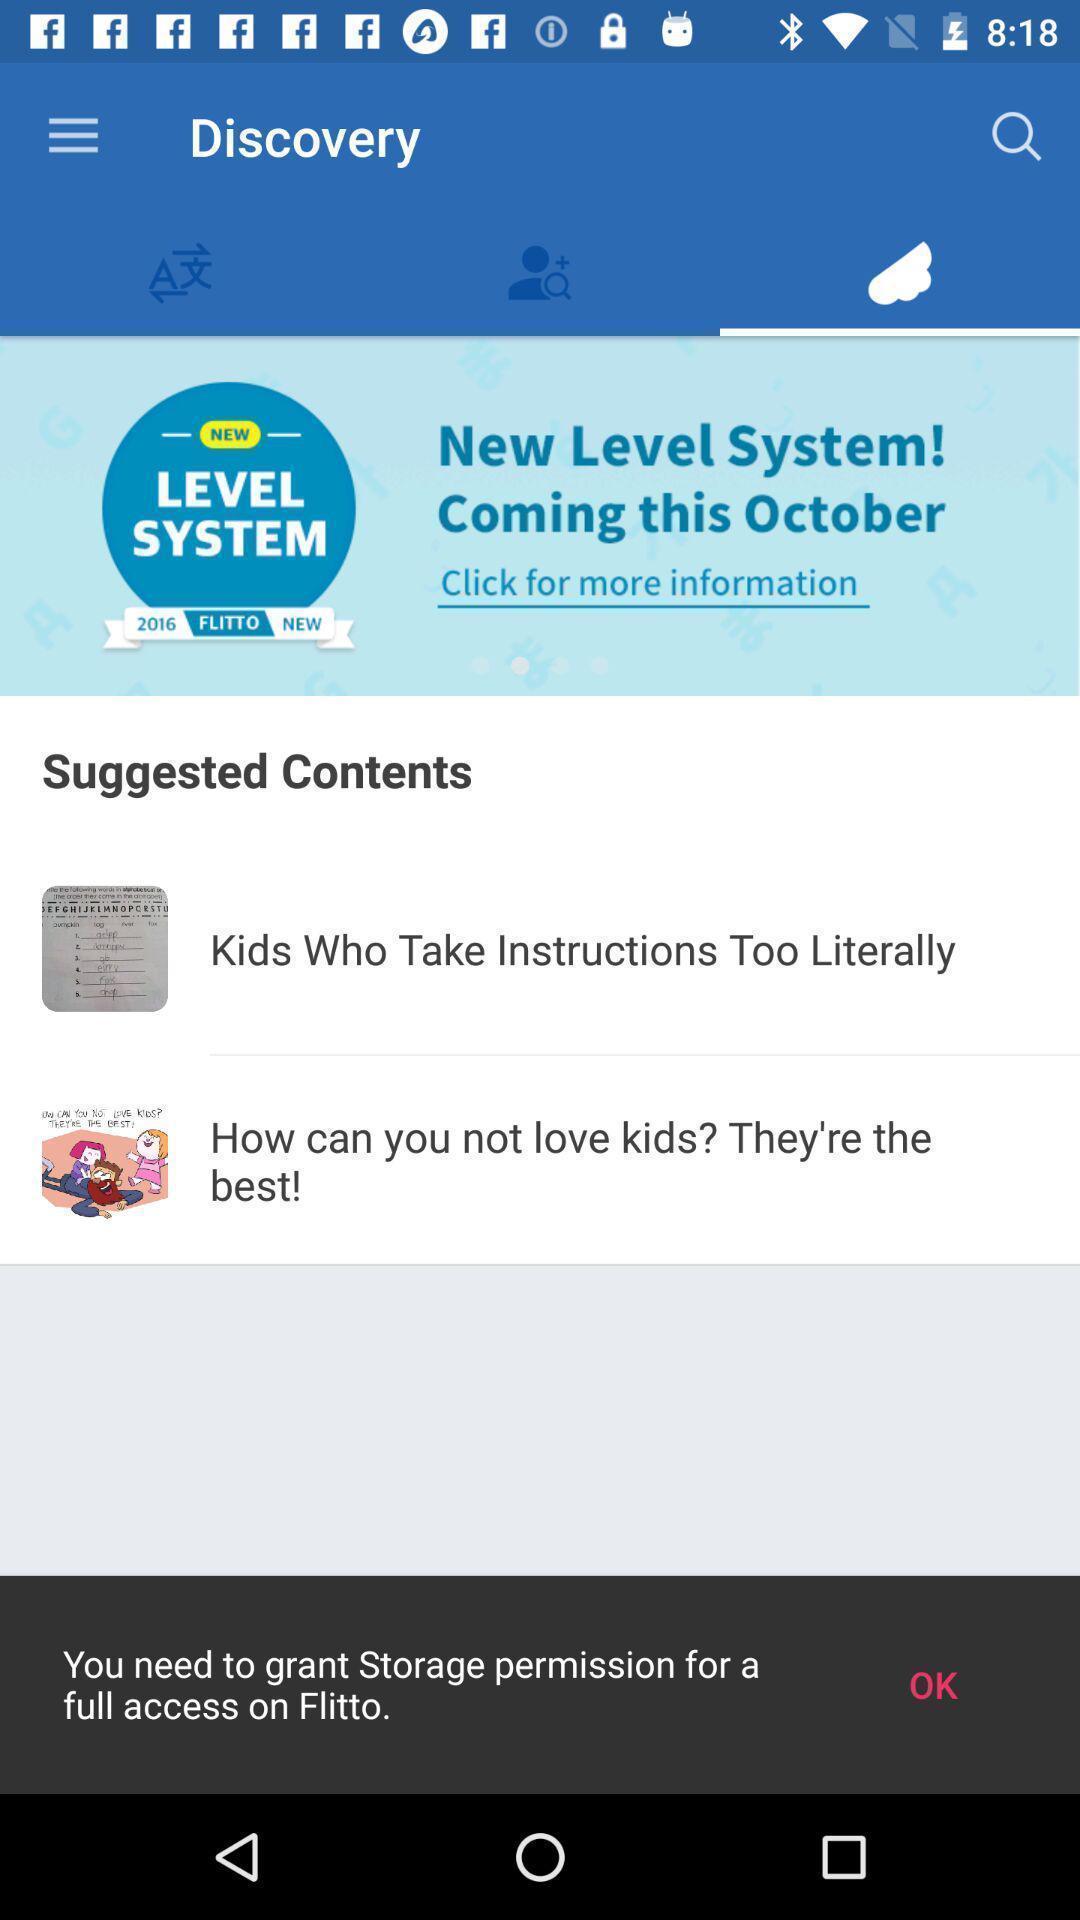Give me a summary of this screen capture. Translating app asking storage permission to get access. 